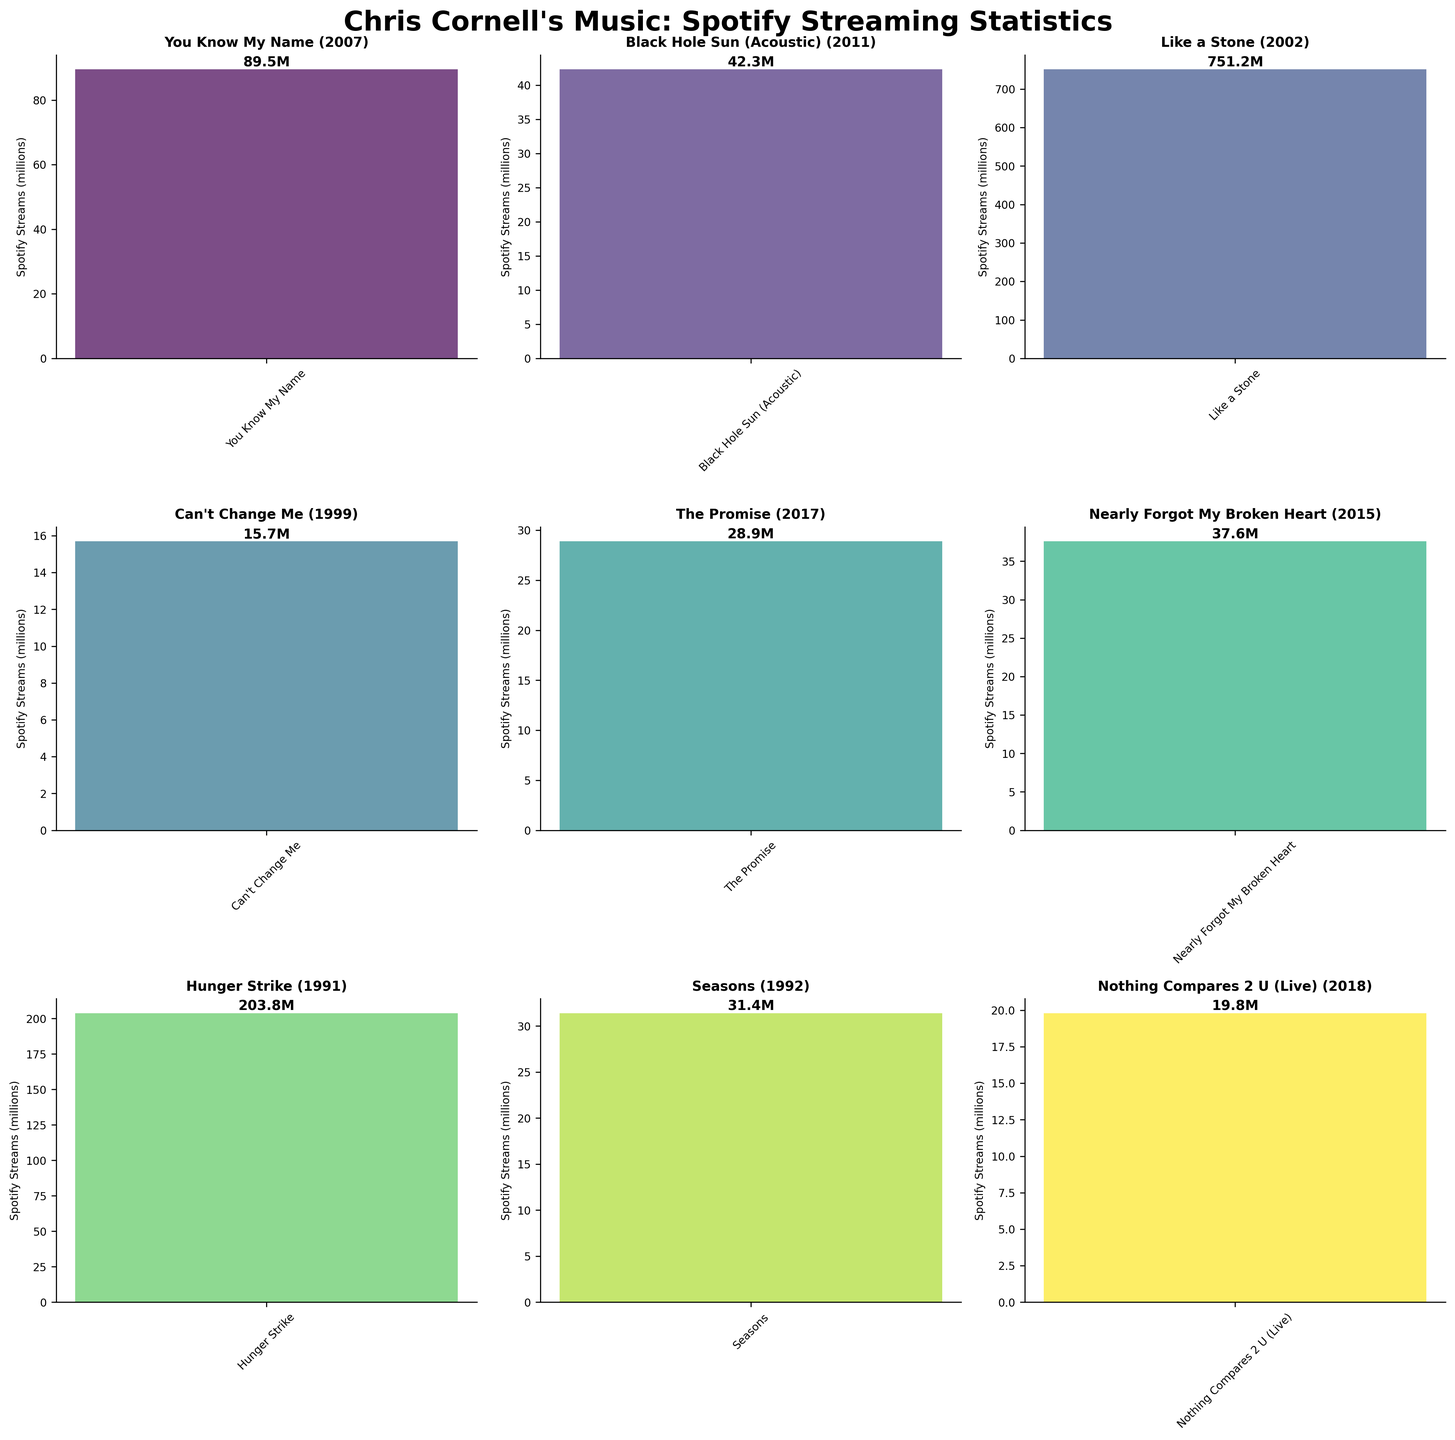What is the title of the figure? The title of the figure is displayed at the top and it reads "Chris Cornell's Music: Spotify Streaming Statistics".
Answer: Chris Cornell's Music: Spotify Streaming Statistics How many songs are visualized in total? The figure consists of 3 rows and 3 columns of subplots, each representing one song. Therefore, there are a total of 9 songs visualized.
Answer: 9 Which song has the highest number of Spotify streams? By examining the height of the bars, "Like a Stone" has the highest stream count as its bar is the tallest.
Answer: "Like a Stone" In what year was "Can't Change Me" released? The release year for "Can't Change Me" is clearly labeled in its subplot title, which is 1999.
Answer: 1999 How many songs from the figure were released after 2000? Looking at the release years in each subplot title, songs released after 2000 are: "You Know My Name" (2007), "Black Hole Sun (Acoustic)" (2011), "Like a Stone" (2002), "The Promise" (2017), "Nearly Forgot My Broken Heart" (2015), and "Nothing Compares 2 U (Live)" (2018). This sums up to 6 songs.
Answer: 6 What is the combined Spotify streams count for "Hunger Strike" and "You Know My Name"? "Hunger Strike" has 203.8 million streams and "You Know My Name" has 89.5 million streams. Adding them gives 203.8 + 89.5 = 293.3 million streams.
Answer: 293.3 million Which song has the least Spotify streams and how many does it have? From the subplot bar heights, "Can't Change Me" has the shortest bar, indicating it has the least streams. The actual number is 15.7 million streams.
Answer: "Can't Change Me", 15.7 million What is the average number of Spotify streams for all the songs? Summing all the streams: 89.5 + 42.3 + 751.2 + 15.7 + 28.9 + 37.6 + 203.8 + 31.4 + 19.8 = 1220.2 million streams. Dividing by the number of songs, 9: 1220.2 / 9 = 135.6 million streams.
Answer: 135.6 million Which song released in the 1990s has more Spotify streams, "Hunger Strike" or "Seasons"? Comparing the Spotify streams, "Hunger Strike" (203.8 million) has more streams than "Seasons" (31.4 million).
Answer: "Hunger Strike" What are the Spotify streams for songs released in 2017 and 2018 combined? Adding the streams for "The Promise" (28.9 million) from 2017 and "Nothing Compares 2 U (Live)" (19.8 million) from 2018: 28.9 + 19.8 = 48.7 million streams.
Answer: 48.7 million 